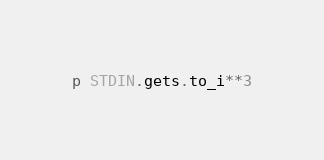Convert code to text. <code><loc_0><loc_0><loc_500><loc_500><_Ruby_>p STDIN.gets.to_i**3</code> 